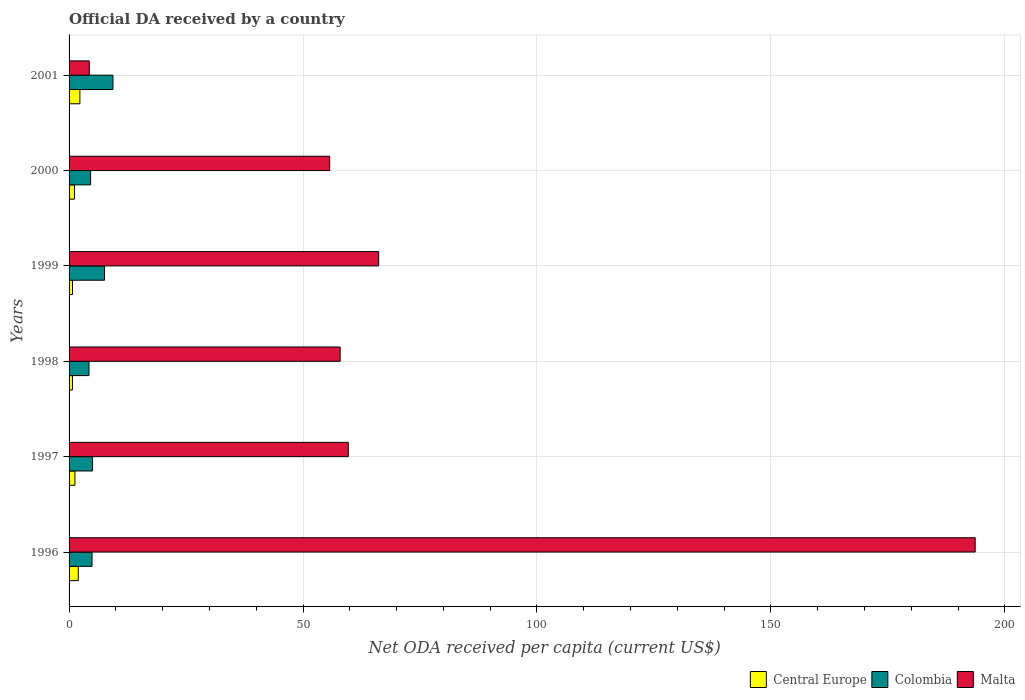How many groups of bars are there?
Provide a succinct answer. 6. Are the number of bars on each tick of the Y-axis equal?
Offer a terse response. Yes. How many bars are there on the 1st tick from the top?
Provide a succinct answer. 3. How many bars are there on the 2nd tick from the bottom?
Your answer should be compact. 3. What is the label of the 2nd group of bars from the top?
Your answer should be very brief. 2000. What is the ODA received in in Colombia in 1996?
Your answer should be very brief. 4.91. Across all years, what is the maximum ODA received in in Central Europe?
Provide a short and direct response. 2.31. Across all years, what is the minimum ODA received in in Malta?
Give a very brief answer. 4.33. What is the total ODA received in in Central Europe in the graph?
Offer a terse response. 8.15. What is the difference between the ODA received in in Malta in 1998 and that in 1999?
Your answer should be very brief. -8.23. What is the difference between the ODA received in in Malta in 1996 and the ODA received in in Central Europe in 2001?
Your answer should be very brief. 191.33. What is the average ODA received in in Malta per year?
Your answer should be compact. 72.91. In the year 1997, what is the difference between the ODA received in in Central Europe and ODA received in in Colombia?
Give a very brief answer. -3.77. In how many years, is the ODA received in in Colombia greater than 190 US$?
Make the answer very short. 0. What is the ratio of the ODA received in in Malta in 1999 to that in 2000?
Offer a very short reply. 1.19. Is the ODA received in in Central Europe in 1998 less than that in 1999?
Your answer should be compact. Yes. What is the difference between the highest and the second highest ODA received in in Malta?
Your response must be concise. 127.48. What is the difference between the highest and the lowest ODA received in in Malta?
Your answer should be compact. 189.32. What does the 2nd bar from the top in 1996 represents?
Your answer should be very brief. Colombia. What does the 2nd bar from the bottom in 1996 represents?
Offer a terse response. Colombia. Is it the case that in every year, the sum of the ODA received in in Malta and ODA received in in Colombia is greater than the ODA received in in Central Europe?
Give a very brief answer. Yes. How many bars are there?
Offer a terse response. 18. What is the difference between two consecutive major ticks on the X-axis?
Your answer should be very brief. 50. Does the graph contain grids?
Provide a short and direct response. Yes. Where does the legend appear in the graph?
Provide a short and direct response. Bottom right. How many legend labels are there?
Your response must be concise. 3. What is the title of the graph?
Your response must be concise. Official DA received by a country. Does "Comoros" appear as one of the legend labels in the graph?
Ensure brevity in your answer.  No. What is the label or title of the X-axis?
Your answer should be very brief. Net ODA received per capita (current US$). What is the label or title of the Y-axis?
Give a very brief answer. Years. What is the Net ODA received per capita (current US$) of Central Europe in 1996?
Make the answer very short. 1.97. What is the Net ODA received per capita (current US$) of Colombia in 1996?
Offer a very short reply. 4.91. What is the Net ODA received per capita (current US$) of Malta in 1996?
Provide a succinct answer. 193.65. What is the Net ODA received per capita (current US$) in Central Europe in 1997?
Your response must be concise. 1.25. What is the Net ODA received per capita (current US$) of Colombia in 1997?
Offer a terse response. 5.02. What is the Net ODA received per capita (current US$) in Malta in 1997?
Ensure brevity in your answer.  59.67. What is the Net ODA received per capita (current US$) of Central Europe in 1998?
Your response must be concise. 0.72. What is the Net ODA received per capita (current US$) of Colombia in 1998?
Provide a short and direct response. 4.26. What is the Net ODA received per capita (current US$) of Malta in 1998?
Give a very brief answer. 57.93. What is the Net ODA received per capita (current US$) in Central Europe in 1999?
Keep it short and to the point. 0.73. What is the Net ODA received per capita (current US$) in Colombia in 1999?
Offer a terse response. 7.57. What is the Net ODA received per capita (current US$) of Malta in 1999?
Make the answer very short. 66.16. What is the Net ODA received per capita (current US$) of Central Europe in 2000?
Offer a terse response. 1.17. What is the Net ODA received per capita (current US$) of Colombia in 2000?
Make the answer very short. 4.6. What is the Net ODA received per capita (current US$) of Malta in 2000?
Give a very brief answer. 55.69. What is the Net ODA received per capita (current US$) in Central Europe in 2001?
Your answer should be very brief. 2.31. What is the Net ODA received per capita (current US$) of Colombia in 2001?
Provide a short and direct response. 9.38. What is the Net ODA received per capita (current US$) of Malta in 2001?
Your response must be concise. 4.33. Across all years, what is the maximum Net ODA received per capita (current US$) in Central Europe?
Your answer should be compact. 2.31. Across all years, what is the maximum Net ODA received per capita (current US$) of Colombia?
Offer a very short reply. 9.38. Across all years, what is the maximum Net ODA received per capita (current US$) in Malta?
Keep it short and to the point. 193.65. Across all years, what is the minimum Net ODA received per capita (current US$) in Central Europe?
Give a very brief answer. 0.72. Across all years, what is the minimum Net ODA received per capita (current US$) in Colombia?
Your answer should be very brief. 4.26. Across all years, what is the minimum Net ODA received per capita (current US$) in Malta?
Your response must be concise. 4.33. What is the total Net ODA received per capita (current US$) in Central Europe in the graph?
Make the answer very short. 8.15. What is the total Net ODA received per capita (current US$) of Colombia in the graph?
Your answer should be compact. 35.75. What is the total Net ODA received per capita (current US$) of Malta in the graph?
Your response must be concise. 437.43. What is the difference between the Net ODA received per capita (current US$) of Central Europe in 1996 and that in 1997?
Keep it short and to the point. 0.72. What is the difference between the Net ODA received per capita (current US$) in Colombia in 1996 and that in 1997?
Your answer should be compact. -0.11. What is the difference between the Net ODA received per capita (current US$) of Malta in 1996 and that in 1997?
Your answer should be very brief. 133.98. What is the difference between the Net ODA received per capita (current US$) in Central Europe in 1996 and that in 1998?
Provide a short and direct response. 1.24. What is the difference between the Net ODA received per capita (current US$) of Colombia in 1996 and that in 1998?
Ensure brevity in your answer.  0.65. What is the difference between the Net ODA received per capita (current US$) of Malta in 1996 and that in 1998?
Provide a short and direct response. 135.72. What is the difference between the Net ODA received per capita (current US$) in Central Europe in 1996 and that in 1999?
Keep it short and to the point. 1.24. What is the difference between the Net ODA received per capita (current US$) of Colombia in 1996 and that in 1999?
Your answer should be compact. -2.66. What is the difference between the Net ODA received per capita (current US$) of Malta in 1996 and that in 1999?
Your response must be concise. 127.48. What is the difference between the Net ODA received per capita (current US$) of Central Europe in 1996 and that in 2000?
Keep it short and to the point. 0.8. What is the difference between the Net ODA received per capita (current US$) in Colombia in 1996 and that in 2000?
Your answer should be compact. 0.31. What is the difference between the Net ODA received per capita (current US$) in Malta in 1996 and that in 2000?
Make the answer very short. 137.95. What is the difference between the Net ODA received per capita (current US$) in Central Europe in 1996 and that in 2001?
Make the answer very short. -0.35. What is the difference between the Net ODA received per capita (current US$) in Colombia in 1996 and that in 2001?
Your response must be concise. -4.47. What is the difference between the Net ODA received per capita (current US$) of Malta in 1996 and that in 2001?
Provide a succinct answer. 189.32. What is the difference between the Net ODA received per capita (current US$) of Central Europe in 1997 and that in 1998?
Your response must be concise. 0.53. What is the difference between the Net ODA received per capita (current US$) in Colombia in 1997 and that in 1998?
Provide a succinct answer. 0.76. What is the difference between the Net ODA received per capita (current US$) in Malta in 1997 and that in 1998?
Provide a short and direct response. 1.74. What is the difference between the Net ODA received per capita (current US$) in Central Europe in 1997 and that in 1999?
Keep it short and to the point. 0.52. What is the difference between the Net ODA received per capita (current US$) in Colombia in 1997 and that in 1999?
Provide a succinct answer. -2.55. What is the difference between the Net ODA received per capita (current US$) in Malta in 1997 and that in 1999?
Provide a succinct answer. -6.5. What is the difference between the Net ODA received per capita (current US$) in Central Europe in 1997 and that in 2000?
Provide a succinct answer. 0.09. What is the difference between the Net ODA received per capita (current US$) of Colombia in 1997 and that in 2000?
Your response must be concise. 0.42. What is the difference between the Net ODA received per capita (current US$) of Malta in 1997 and that in 2000?
Offer a very short reply. 3.97. What is the difference between the Net ODA received per capita (current US$) of Central Europe in 1997 and that in 2001?
Provide a succinct answer. -1.06. What is the difference between the Net ODA received per capita (current US$) of Colombia in 1997 and that in 2001?
Provide a succinct answer. -4.35. What is the difference between the Net ODA received per capita (current US$) of Malta in 1997 and that in 2001?
Offer a very short reply. 55.34. What is the difference between the Net ODA received per capita (current US$) of Central Europe in 1998 and that in 1999?
Your answer should be compact. -0. What is the difference between the Net ODA received per capita (current US$) in Colombia in 1998 and that in 1999?
Your answer should be compact. -3.32. What is the difference between the Net ODA received per capita (current US$) of Malta in 1998 and that in 1999?
Offer a terse response. -8.23. What is the difference between the Net ODA received per capita (current US$) of Central Europe in 1998 and that in 2000?
Ensure brevity in your answer.  -0.44. What is the difference between the Net ODA received per capita (current US$) in Colombia in 1998 and that in 2000?
Give a very brief answer. -0.34. What is the difference between the Net ODA received per capita (current US$) of Malta in 1998 and that in 2000?
Keep it short and to the point. 2.24. What is the difference between the Net ODA received per capita (current US$) of Central Europe in 1998 and that in 2001?
Give a very brief answer. -1.59. What is the difference between the Net ODA received per capita (current US$) in Colombia in 1998 and that in 2001?
Make the answer very short. -5.12. What is the difference between the Net ODA received per capita (current US$) of Malta in 1998 and that in 2001?
Provide a succinct answer. 53.61. What is the difference between the Net ODA received per capita (current US$) in Central Europe in 1999 and that in 2000?
Your answer should be compact. -0.44. What is the difference between the Net ODA received per capita (current US$) of Colombia in 1999 and that in 2000?
Provide a short and direct response. 2.97. What is the difference between the Net ODA received per capita (current US$) in Malta in 1999 and that in 2000?
Offer a terse response. 10.47. What is the difference between the Net ODA received per capita (current US$) of Central Europe in 1999 and that in 2001?
Keep it short and to the point. -1.58. What is the difference between the Net ODA received per capita (current US$) in Colombia in 1999 and that in 2001?
Offer a very short reply. -1.8. What is the difference between the Net ODA received per capita (current US$) in Malta in 1999 and that in 2001?
Provide a succinct answer. 61.84. What is the difference between the Net ODA received per capita (current US$) of Central Europe in 2000 and that in 2001?
Your answer should be compact. -1.15. What is the difference between the Net ODA received per capita (current US$) in Colombia in 2000 and that in 2001?
Give a very brief answer. -4.78. What is the difference between the Net ODA received per capita (current US$) of Malta in 2000 and that in 2001?
Offer a very short reply. 51.37. What is the difference between the Net ODA received per capita (current US$) in Central Europe in 1996 and the Net ODA received per capita (current US$) in Colombia in 1997?
Provide a succinct answer. -3.06. What is the difference between the Net ODA received per capita (current US$) of Central Europe in 1996 and the Net ODA received per capita (current US$) of Malta in 1997?
Your answer should be compact. -57.7. What is the difference between the Net ODA received per capita (current US$) of Colombia in 1996 and the Net ODA received per capita (current US$) of Malta in 1997?
Provide a short and direct response. -54.76. What is the difference between the Net ODA received per capita (current US$) of Central Europe in 1996 and the Net ODA received per capita (current US$) of Colombia in 1998?
Provide a short and direct response. -2.29. What is the difference between the Net ODA received per capita (current US$) in Central Europe in 1996 and the Net ODA received per capita (current US$) in Malta in 1998?
Ensure brevity in your answer.  -55.96. What is the difference between the Net ODA received per capita (current US$) in Colombia in 1996 and the Net ODA received per capita (current US$) in Malta in 1998?
Ensure brevity in your answer.  -53.02. What is the difference between the Net ODA received per capita (current US$) in Central Europe in 1996 and the Net ODA received per capita (current US$) in Colombia in 1999?
Offer a very short reply. -5.61. What is the difference between the Net ODA received per capita (current US$) of Central Europe in 1996 and the Net ODA received per capita (current US$) of Malta in 1999?
Ensure brevity in your answer.  -64.2. What is the difference between the Net ODA received per capita (current US$) in Colombia in 1996 and the Net ODA received per capita (current US$) in Malta in 1999?
Give a very brief answer. -61.25. What is the difference between the Net ODA received per capita (current US$) in Central Europe in 1996 and the Net ODA received per capita (current US$) in Colombia in 2000?
Give a very brief answer. -2.63. What is the difference between the Net ODA received per capita (current US$) of Central Europe in 1996 and the Net ODA received per capita (current US$) of Malta in 2000?
Offer a very short reply. -53.73. What is the difference between the Net ODA received per capita (current US$) of Colombia in 1996 and the Net ODA received per capita (current US$) of Malta in 2000?
Your answer should be very brief. -50.78. What is the difference between the Net ODA received per capita (current US$) of Central Europe in 1996 and the Net ODA received per capita (current US$) of Colombia in 2001?
Keep it short and to the point. -7.41. What is the difference between the Net ODA received per capita (current US$) in Central Europe in 1996 and the Net ODA received per capita (current US$) in Malta in 2001?
Offer a terse response. -2.36. What is the difference between the Net ODA received per capita (current US$) in Colombia in 1996 and the Net ODA received per capita (current US$) in Malta in 2001?
Your answer should be compact. 0.59. What is the difference between the Net ODA received per capita (current US$) of Central Europe in 1997 and the Net ODA received per capita (current US$) of Colombia in 1998?
Ensure brevity in your answer.  -3.01. What is the difference between the Net ODA received per capita (current US$) in Central Europe in 1997 and the Net ODA received per capita (current US$) in Malta in 1998?
Provide a short and direct response. -56.68. What is the difference between the Net ODA received per capita (current US$) of Colombia in 1997 and the Net ODA received per capita (current US$) of Malta in 1998?
Your answer should be compact. -52.91. What is the difference between the Net ODA received per capita (current US$) of Central Europe in 1997 and the Net ODA received per capita (current US$) of Colombia in 1999?
Your answer should be very brief. -6.32. What is the difference between the Net ODA received per capita (current US$) of Central Europe in 1997 and the Net ODA received per capita (current US$) of Malta in 1999?
Provide a short and direct response. -64.91. What is the difference between the Net ODA received per capita (current US$) in Colombia in 1997 and the Net ODA received per capita (current US$) in Malta in 1999?
Make the answer very short. -61.14. What is the difference between the Net ODA received per capita (current US$) in Central Europe in 1997 and the Net ODA received per capita (current US$) in Colombia in 2000?
Offer a terse response. -3.35. What is the difference between the Net ODA received per capita (current US$) in Central Europe in 1997 and the Net ODA received per capita (current US$) in Malta in 2000?
Make the answer very short. -54.44. What is the difference between the Net ODA received per capita (current US$) in Colombia in 1997 and the Net ODA received per capita (current US$) in Malta in 2000?
Give a very brief answer. -50.67. What is the difference between the Net ODA received per capita (current US$) of Central Europe in 1997 and the Net ODA received per capita (current US$) of Colombia in 2001?
Keep it short and to the point. -8.13. What is the difference between the Net ODA received per capita (current US$) of Central Europe in 1997 and the Net ODA received per capita (current US$) of Malta in 2001?
Your answer should be very brief. -3.07. What is the difference between the Net ODA received per capita (current US$) in Colombia in 1997 and the Net ODA received per capita (current US$) in Malta in 2001?
Provide a short and direct response. 0.7. What is the difference between the Net ODA received per capita (current US$) of Central Europe in 1998 and the Net ODA received per capita (current US$) of Colombia in 1999?
Your answer should be very brief. -6.85. What is the difference between the Net ODA received per capita (current US$) in Central Europe in 1998 and the Net ODA received per capita (current US$) in Malta in 1999?
Ensure brevity in your answer.  -65.44. What is the difference between the Net ODA received per capita (current US$) in Colombia in 1998 and the Net ODA received per capita (current US$) in Malta in 1999?
Keep it short and to the point. -61.91. What is the difference between the Net ODA received per capita (current US$) in Central Europe in 1998 and the Net ODA received per capita (current US$) in Colombia in 2000?
Provide a short and direct response. -3.88. What is the difference between the Net ODA received per capita (current US$) in Central Europe in 1998 and the Net ODA received per capita (current US$) in Malta in 2000?
Keep it short and to the point. -54.97. What is the difference between the Net ODA received per capita (current US$) of Colombia in 1998 and the Net ODA received per capita (current US$) of Malta in 2000?
Your response must be concise. -51.44. What is the difference between the Net ODA received per capita (current US$) in Central Europe in 1998 and the Net ODA received per capita (current US$) in Colombia in 2001?
Provide a succinct answer. -8.65. What is the difference between the Net ODA received per capita (current US$) in Central Europe in 1998 and the Net ODA received per capita (current US$) in Malta in 2001?
Ensure brevity in your answer.  -3.6. What is the difference between the Net ODA received per capita (current US$) of Colombia in 1998 and the Net ODA received per capita (current US$) of Malta in 2001?
Provide a short and direct response. -0.07. What is the difference between the Net ODA received per capita (current US$) of Central Europe in 1999 and the Net ODA received per capita (current US$) of Colombia in 2000?
Your answer should be very brief. -3.87. What is the difference between the Net ODA received per capita (current US$) of Central Europe in 1999 and the Net ODA received per capita (current US$) of Malta in 2000?
Provide a succinct answer. -54.97. What is the difference between the Net ODA received per capita (current US$) of Colombia in 1999 and the Net ODA received per capita (current US$) of Malta in 2000?
Give a very brief answer. -48.12. What is the difference between the Net ODA received per capita (current US$) in Central Europe in 1999 and the Net ODA received per capita (current US$) in Colombia in 2001?
Keep it short and to the point. -8.65. What is the difference between the Net ODA received per capita (current US$) of Central Europe in 1999 and the Net ODA received per capita (current US$) of Malta in 2001?
Your answer should be very brief. -3.6. What is the difference between the Net ODA received per capita (current US$) of Colombia in 1999 and the Net ODA received per capita (current US$) of Malta in 2001?
Your answer should be compact. 3.25. What is the difference between the Net ODA received per capita (current US$) of Central Europe in 2000 and the Net ODA received per capita (current US$) of Colombia in 2001?
Offer a very short reply. -8.21. What is the difference between the Net ODA received per capita (current US$) in Central Europe in 2000 and the Net ODA received per capita (current US$) in Malta in 2001?
Make the answer very short. -3.16. What is the difference between the Net ODA received per capita (current US$) in Colombia in 2000 and the Net ODA received per capita (current US$) in Malta in 2001?
Offer a very short reply. 0.28. What is the average Net ODA received per capita (current US$) in Central Europe per year?
Your response must be concise. 1.36. What is the average Net ODA received per capita (current US$) of Colombia per year?
Keep it short and to the point. 5.96. What is the average Net ODA received per capita (current US$) in Malta per year?
Offer a terse response. 72.91. In the year 1996, what is the difference between the Net ODA received per capita (current US$) of Central Europe and Net ODA received per capita (current US$) of Colombia?
Your response must be concise. -2.94. In the year 1996, what is the difference between the Net ODA received per capita (current US$) in Central Europe and Net ODA received per capita (current US$) in Malta?
Provide a succinct answer. -191.68. In the year 1996, what is the difference between the Net ODA received per capita (current US$) of Colombia and Net ODA received per capita (current US$) of Malta?
Your answer should be compact. -188.74. In the year 1997, what is the difference between the Net ODA received per capita (current US$) of Central Europe and Net ODA received per capita (current US$) of Colombia?
Provide a short and direct response. -3.77. In the year 1997, what is the difference between the Net ODA received per capita (current US$) of Central Europe and Net ODA received per capita (current US$) of Malta?
Give a very brief answer. -58.42. In the year 1997, what is the difference between the Net ODA received per capita (current US$) of Colombia and Net ODA received per capita (current US$) of Malta?
Your response must be concise. -54.65. In the year 1998, what is the difference between the Net ODA received per capita (current US$) in Central Europe and Net ODA received per capita (current US$) in Colombia?
Your answer should be compact. -3.53. In the year 1998, what is the difference between the Net ODA received per capita (current US$) in Central Europe and Net ODA received per capita (current US$) in Malta?
Provide a succinct answer. -57.21. In the year 1998, what is the difference between the Net ODA received per capita (current US$) in Colombia and Net ODA received per capita (current US$) in Malta?
Make the answer very short. -53.67. In the year 1999, what is the difference between the Net ODA received per capita (current US$) in Central Europe and Net ODA received per capita (current US$) in Colombia?
Keep it short and to the point. -6.85. In the year 1999, what is the difference between the Net ODA received per capita (current US$) in Central Europe and Net ODA received per capita (current US$) in Malta?
Your response must be concise. -65.44. In the year 1999, what is the difference between the Net ODA received per capita (current US$) of Colombia and Net ODA received per capita (current US$) of Malta?
Provide a succinct answer. -58.59. In the year 2000, what is the difference between the Net ODA received per capita (current US$) of Central Europe and Net ODA received per capita (current US$) of Colombia?
Offer a very short reply. -3.44. In the year 2000, what is the difference between the Net ODA received per capita (current US$) in Central Europe and Net ODA received per capita (current US$) in Malta?
Ensure brevity in your answer.  -54.53. In the year 2000, what is the difference between the Net ODA received per capita (current US$) in Colombia and Net ODA received per capita (current US$) in Malta?
Provide a short and direct response. -51.09. In the year 2001, what is the difference between the Net ODA received per capita (current US$) in Central Europe and Net ODA received per capita (current US$) in Colombia?
Give a very brief answer. -7.06. In the year 2001, what is the difference between the Net ODA received per capita (current US$) of Central Europe and Net ODA received per capita (current US$) of Malta?
Offer a very short reply. -2.01. In the year 2001, what is the difference between the Net ODA received per capita (current US$) of Colombia and Net ODA received per capita (current US$) of Malta?
Provide a succinct answer. 5.05. What is the ratio of the Net ODA received per capita (current US$) of Central Europe in 1996 to that in 1997?
Provide a short and direct response. 1.57. What is the ratio of the Net ODA received per capita (current US$) in Colombia in 1996 to that in 1997?
Ensure brevity in your answer.  0.98. What is the ratio of the Net ODA received per capita (current US$) of Malta in 1996 to that in 1997?
Your answer should be compact. 3.25. What is the ratio of the Net ODA received per capita (current US$) in Central Europe in 1996 to that in 1998?
Give a very brief answer. 2.71. What is the ratio of the Net ODA received per capita (current US$) in Colombia in 1996 to that in 1998?
Keep it short and to the point. 1.15. What is the ratio of the Net ODA received per capita (current US$) of Malta in 1996 to that in 1998?
Your answer should be compact. 3.34. What is the ratio of the Net ODA received per capita (current US$) in Central Europe in 1996 to that in 1999?
Provide a short and direct response. 2.7. What is the ratio of the Net ODA received per capita (current US$) of Colombia in 1996 to that in 1999?
Provide a succinct answer. 0.65. What is the ratio of the Net ODA received per capita (current US$) of Malta in 1996 to that in 1999?
Provide a succinct answer. 2.93. What is the ratio of the Net ODA received per capita (current US$) in Central Europe in 1996 to that in 2000?
Make the answer very short. 1.69. What is the ratio of the Net ODA received per capita (current US$) of Colombia in 1996 to that in 2000?
Make the answer very short. 1.07. What is the ratio of the Net ODA received per capita (current US$) in Malta in 1996 to that in 2000?
Offer a very short reply. 3.48. What is the ratio of the Net ODA received per capita (current US$) in Central Europe in 1996 to that in 2001?
Offer a very short reply. 0.85. What is the ratio of the Net ODA received per capita (current US$) of Colombia in 1996 to that in 2001?
Give a very brief answer. 0.52. What is the ratio of the Net ODA received per capita (current US$) in Malta in 1996 to that in 2001?
Your answer should be very brief. 44.77. What is the ratio of the Net ODA received per capita (current US$) in Central Europe in 1997 to that in 1998?
Keep it short and to the point. 1.73. What is the ratio of the Net ODA received per capita (current US$) in Colombia in 1997 to that in 1998?
Make the answer very short. 1.18. What is the ratio of the Net ODA received per capita (current US$) in Malta in 1997 to that in 1998?
Provide a succinct answer. 1.03. What is the ratio of the Net ODA received per capita (current US$) of Central Europe in 1997 to that in 1999?
Your answer should be very brief. 1.72. What is the ratio of the Net ODA received per capita (current US$) of Colombia in 1997 to that in 1999?
Your answer should be compact. 0.66. What is the ratio of the Net ODA received per capita (current US$) of Malta in 1997 to that in 1999?
Your response must be concise. 0.9. What is the ratio of the Net ODA received per capita (current US$) of Central Europe in 1997 to that in 2000?
Offer a very short reply. 1.07. What is the ratio of the Net ODA received per capita (current US$) of Colombia in 1997 to that in 2000?
Offer a very short reply. 1.09. What is the ratio of the Net ODA received per capita (current US$) in Malta in 1997 to that in 2000?
Your answer should be very brief. 1.07. What is the ratio of the Net ODA received per capita (current US$) in Central Europe in 1997 to that in 2001?
Offer a very short reply. 0.54. What is the ratio of the Net ODA received per capita (current US$) of Colombia in 1997 to that in 2001?
Ensure brevity in your answer.  0.54. What is the ratio of the Net ODA received per capita (current US$) in Malta in 1997 to that in 2001?
Your answer should be compact. 13.8. What is the ratio of the Net ODA received per capita (current US$) of Colombia in 1998 to that in 1999?
Give a very brief answer. 0.56. What is the ratio of the Net ODA received per capita (current US$) in Malta in 1998 to that in 1999?
Your answer should be compact. 0.88. What is the ratio of the Net ODA received per capita (current US$) in Central Europe in 1998 to that in 2000?
Offer a very short reply. 0.62. What is the ratio of the Net ODA received per capita (current US$) in Colombia in 1998 to that in 2000?
Your response must be concise. 0.93. What is the ratio of the Net ODA received per capita (current US$) in Malta in 1998 to that in 2000?
Your answer should be very brief. 1.04. What is the ratio of the Net ODA received per capita (current US$) in Central Europe in 1998 to that in 2001?
Give a very brief answer. 0.31. What is the ratio of the Net ODA received per capita (current US$) in Colombia in 1998 to that in 2001?
Give a very brief answer. 0.45. What is the ratio of the Net ODA received per capita (current US$) in Malta in 1998 to that in 2001?
Provide a short and direct response. 13.39. What is the ratio of the Net ODA received per capita (current US$) of Central Europe in 1999 to that in 2000?
Provide a short and direct response. 0.63. What is the ratio of the Net ODA received per capita (current US$) of Colombia in 1999 to that in 2000?
Your response must be concise. 1.65. What is the ratio of the Net ODA received per capita (current US$) in Malta in 1999 to that in 2000?
Offer a terse response. 1.19. What is the ratio of the Net ODA received per capita (current US$) of Central Europe in 1999 to that in 2001?
Give a very brief answer. 0.32. What is the ratio of the Net ODA received per capita (current US$) in Colombia in 1999 to that in 2001?
Provide a succinct answer. 0.81. What is the ratio of the Net ODA received per capita (current US$) in Malta in 1999 to that in 2001?
Make the answer very short. 15.3. What is the ratio of the Net ODA received per capita (current US$) of Central Europe in 2000 to that in 2001?
Keep it short and to the point. 0.5. What is the ratio of the Net ODA received per capita (current US$) in Colombia in 2000 to that in 2001?
Ensure brevity in your answer.  0.49. What is the ratio of the Net ODA received per capita (current US$) in Malta in 2000 to that in 2001?
Offer a very short reply. 12.88. What is the difference between the highest and the second highest Net ODA received per capita (current US$) of Central Europe?
Offer a terse response. 0.35. What is the difference between the highest and the second highest Net ODA received per capita (current US$) in Colombia?
Make the answer very short. 1.8. What is the difference between the highest and the second highest Net ODA received per capita (current US$) of Malta?
Provide a succinct answer. 127.48. What is the difference between the highest and the lowest Net ODA received per capita (current US$) in Central Europe?
Offer a very short reply. 1.59. What is the difference between the highest and the lowest Net ODA received per capita (current US$) of Colombia?
Make the answer very short. 5.12. What is the difference between the highest and the lowest Net ODA received per capita (current US$) of Malta?
Your answer should be compact. 189.32. 